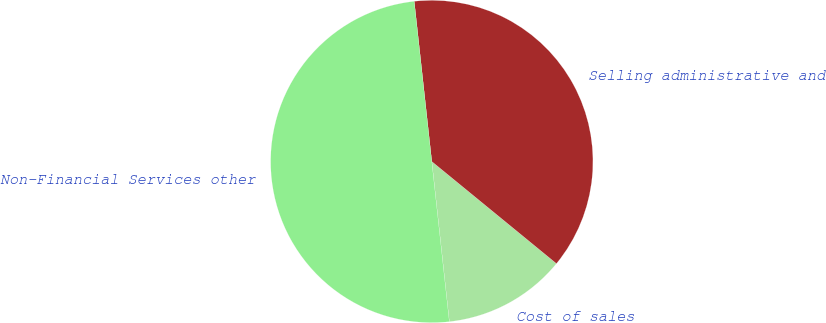<chart> <loc_0><loc_0><loc_500><loc_500><pie_chart><fcel>Cost of sales<fcel>Selling administrative and<fcel>Non-Financial Services other<nl><fcel>12.34%<fcel>37.66%<fcel>50.0%<nl></chart> 